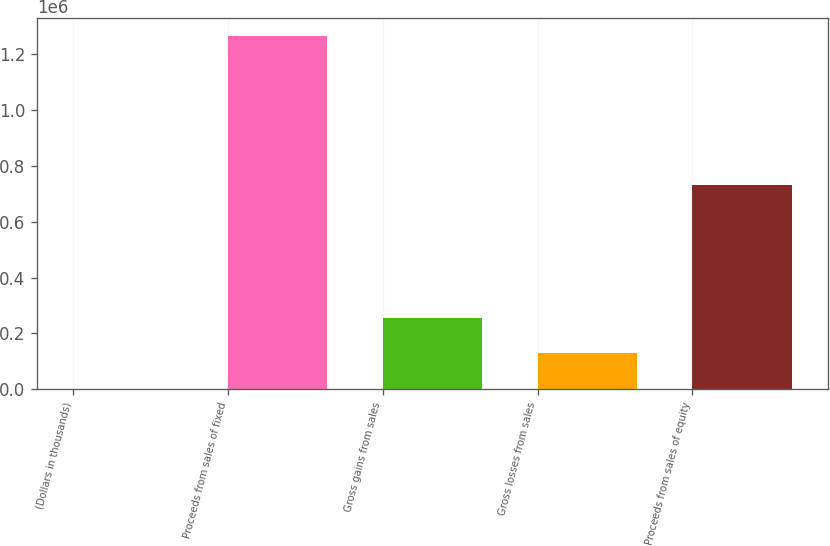Convert chart to OTSL. <chart><loc_0><loc_0><loc_500><loc_500><bar_chart><fcel>(Dollars in thousands)<fcel>Proceeds from sales of fixed<fcel>Gross gains from sales<fcel>Gross losses from sales<fcel>Proceeds from sales of equity<nl><fcel>2016<fcel>1.26427e+06<fcel>254467<fcel>128242<fcel>729782<nl></chart> 